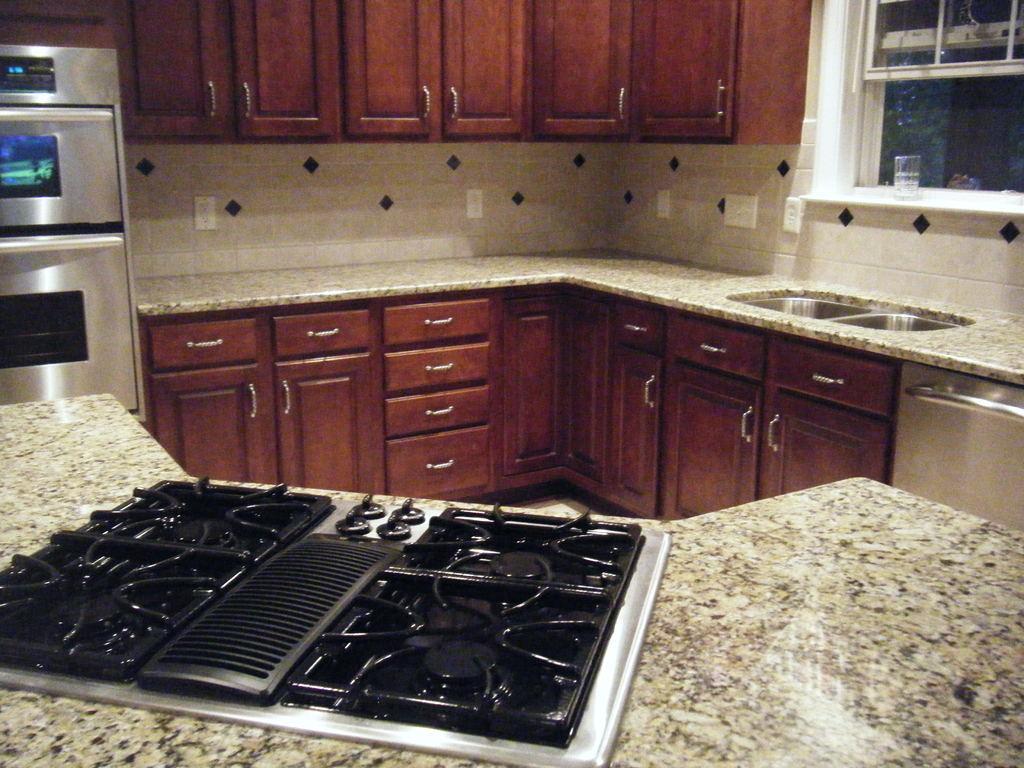How would you summarize this image in a sentence or two? The picture contains a kitchen, there is a stove, a sink and above the sink there is a window. On the left side there is an oven and there are a lot of cupboards below the marble floor and also in front of the wall. 